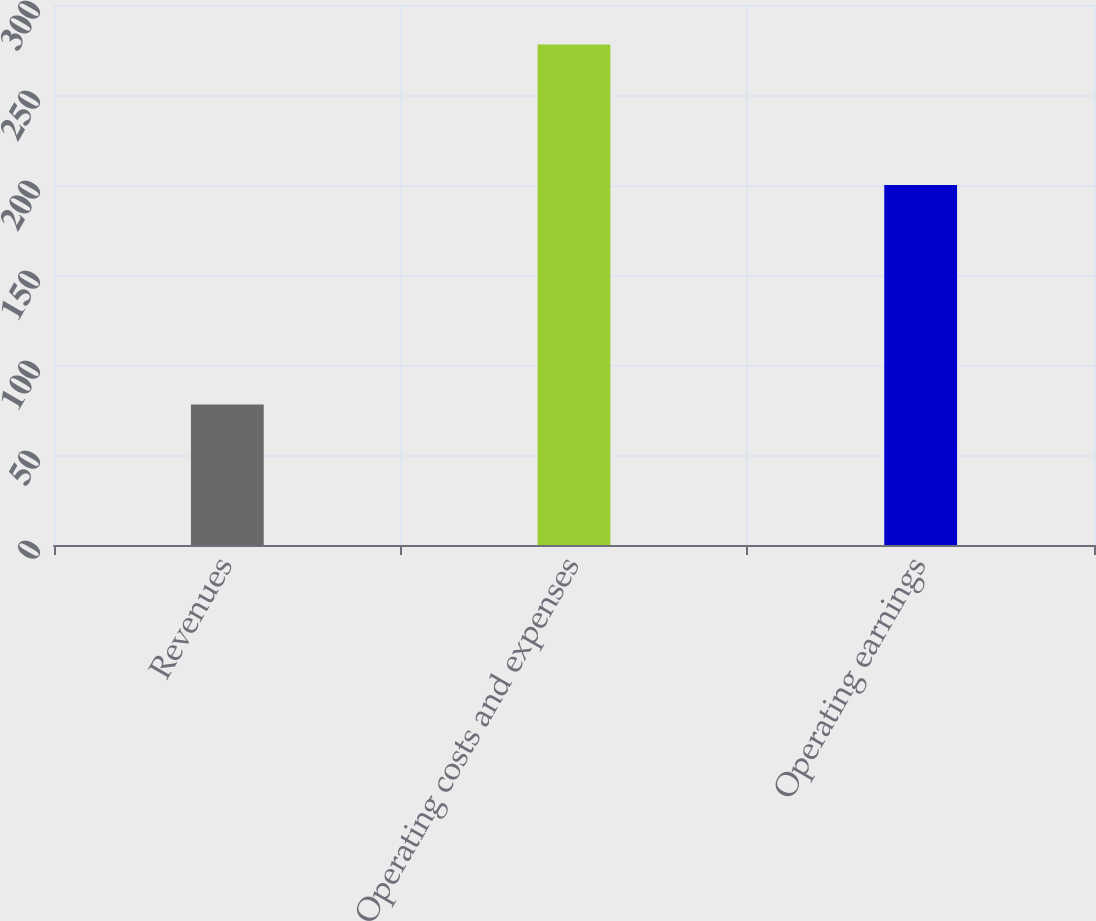Convert chart to OTSL. <chart><loc_0><loc_0><loc_500><loc_500><bar_chart><fcel>Revenues<fcel>Operating costs and expenses<fcel>Operating earnings<nl><fcel>78<fcel>278<fcel>200<nl></chart> 